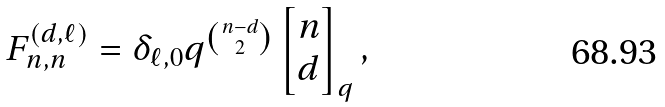<formula> <loc_0><loc_0><loc_500><loc_500>F _ { n , n } ^ { ( d , \ell ) } & = \delta _ { \ell , 0 } q ^ { \binom { n - d } { 2 } } \begin{bmatrix} n \\ d \end{bmatrix} _ { q } ,</formula> 